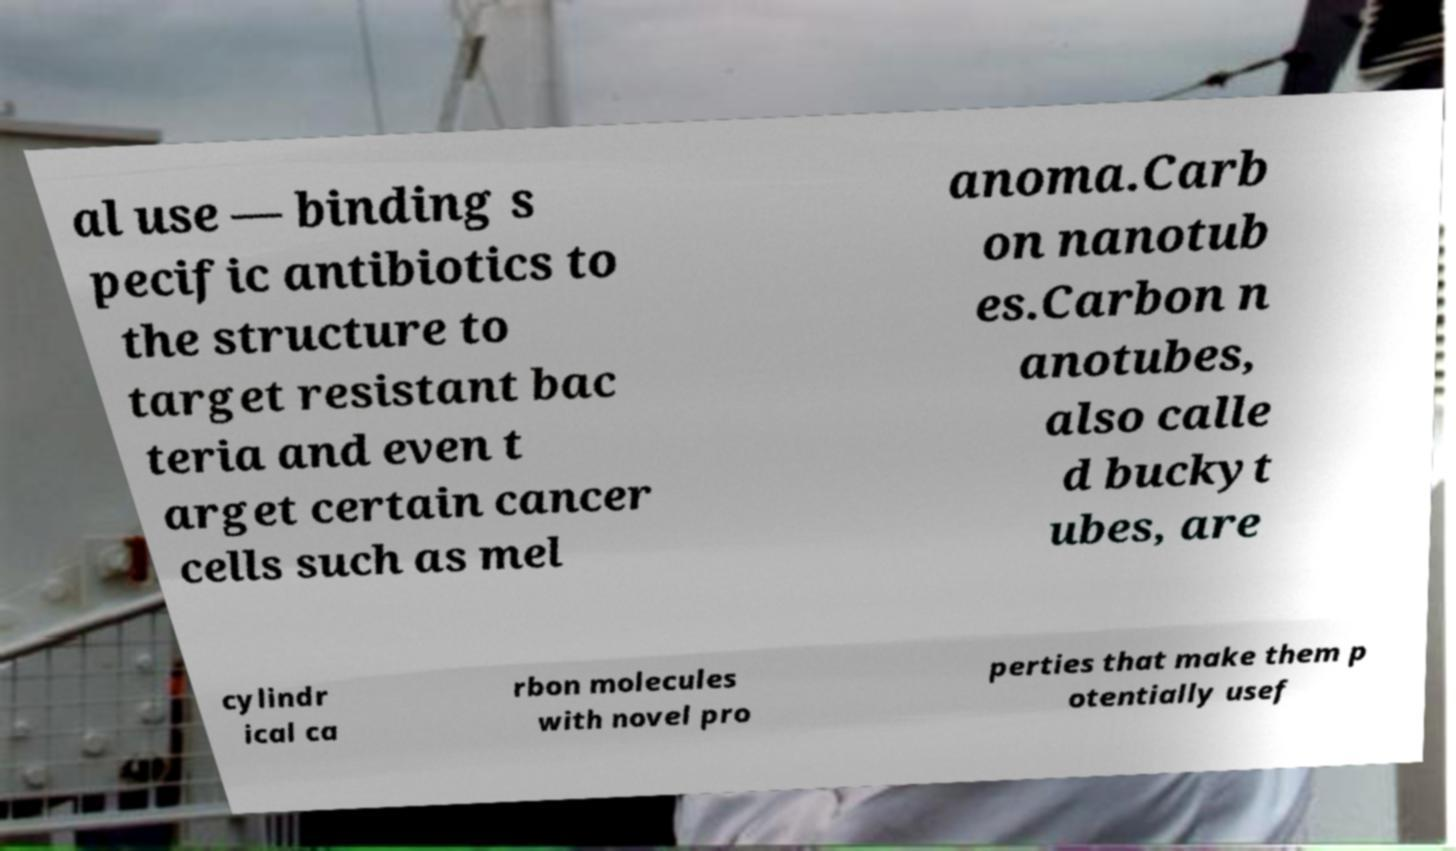I need the written content from this picture converted into text. Can you do that? al use — binding s pecific antibiotics to the structure to target resistant bac teria and even t arget certain cancer cells such as mel anoma.Carb on nanotub es.Carbon n anotubes, also calle d buckyt ubes, are cylindr ical ca rbon molecules with novel pro perties that make them p otentially usef 